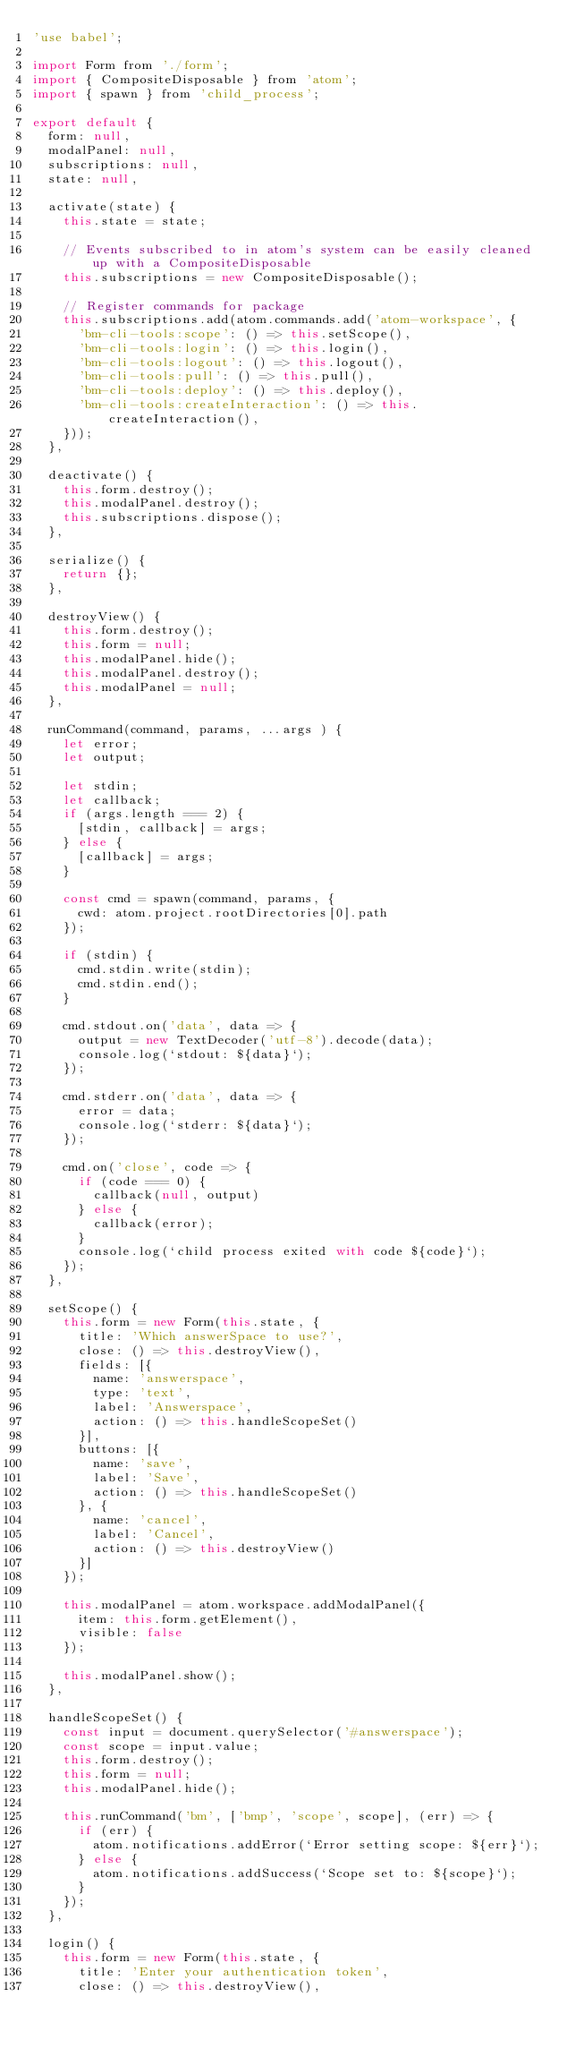<code> <loc_0><loc_0><loc_500><loc_500><_JavaScript_>'use babel';

import Form from './form';
import { CompositeDisposable } from 'atom';
import { spawn } from 'child_process';

export default {
  form: null,
  modalPanel: null,
  subscriptions: null,
  state: null,

  activate(state) {
    this.state = state;

    // Events subscribed to in atom's system can be easily cleaned up with a CompositeDisposable
    this.subscriptions = new CompositeDisposable();

    // Register commands for package
    this.subscriptions.add(atom.commands.add('atom-workspace', {
      'bm-cli-tools:scope': () => this.setScope(),
      'bm-cli-tools:login': () => this.login(),
      'bm-cli-tools:logout': () => this.logout(),
      'bm-cli-tools:pull': () => this.pull(),
      'bm-cli-tools:deploy': () => this.deploy(),
      'bm-cli-tools:createInteraction': () => this.createInteraction(),
    }));
  },

  deactivate() {
    this.form.destroy();
    this.modalPanel.destroy();
    this.subscriptions.dispose();
  },

  serialize() {
    return {};
  },

  destroyView() {
    this.form.destroy();
    this.form = null;
    this.modalPanel.hide();
    this.modalPanel.destroy();
    this.modalPanel = null;
  },

  runCommand(command, params, ...args ) {
    let error;
    let output;

    let stdin;
    let callback;
    if (args.length === 2) {
      [stdin, callback] = args;
    } else {
      [callback] = args;
    }

    const cmd = spawn(command, params, {
      cwd: atom.project.rootDirectories[0].path
    });

    if (stdin) {
      cmd.stdin.write(stdin);
      cmd.stdin.end();
    }

    cmd.stdout.on('data', data => {
      output = new TextDecoder('utf-8').decode(data);
      console.log(`stdout: ${data}`);
    });

    cmd.stderr.on('data', data => {
      error = data;
      console.log(`stderr: ${data}`);
    });

    cmd.on('close', code => {
      if (code === 0) {
        callback(null, output)
      } else {
        callback(error);
      }
      console.log(`child process exited with code ${code}`);
    });
  },

  setScope() {
    this.form = new Form(this.state, {
      title: 'Which answerSpace to use?',
      close: () => this.destroyView(),
      fields: [{
        name: 'answerspace',
        type: 'text',
        label: 'Answerspace',
        action: () => this.handleScopeSet()
      }],
      buttons: [{
        name: 'save',
        label: 'Save',
        action: () => this.handleScopeSet()
      }, {
        name: 'cancel',
        label: 'Cancel',
        action: () => this.destroyView()
      }]
    });

    this.modalPanel = atom.workspace.addModalPanel({
      item: this.form.getElement(),
      visible: false
    });

    this.modalPanel.show();
  },

  handleScopeSet() {
    const input = document.querySelector('#answerspace');
    const scope = input.value;
    this.form.destroy();
    this.form = null;
    this.modalPanel.hide();

    this.runCommand('bm', ['bmp', 'scope', scope], (err) => {
      if (err) {
        atom.notifications.addError(`Error setting scope: ${err}`);
      } else {
        atom.notifications.addSuccess(`Scope set to: ${scope}`);
      }
    });
  },

  login() {
    this.form = new Form(this.state, {
      title: 'Enter your authentication token',
      close: () => this.destroyView(),</code> 